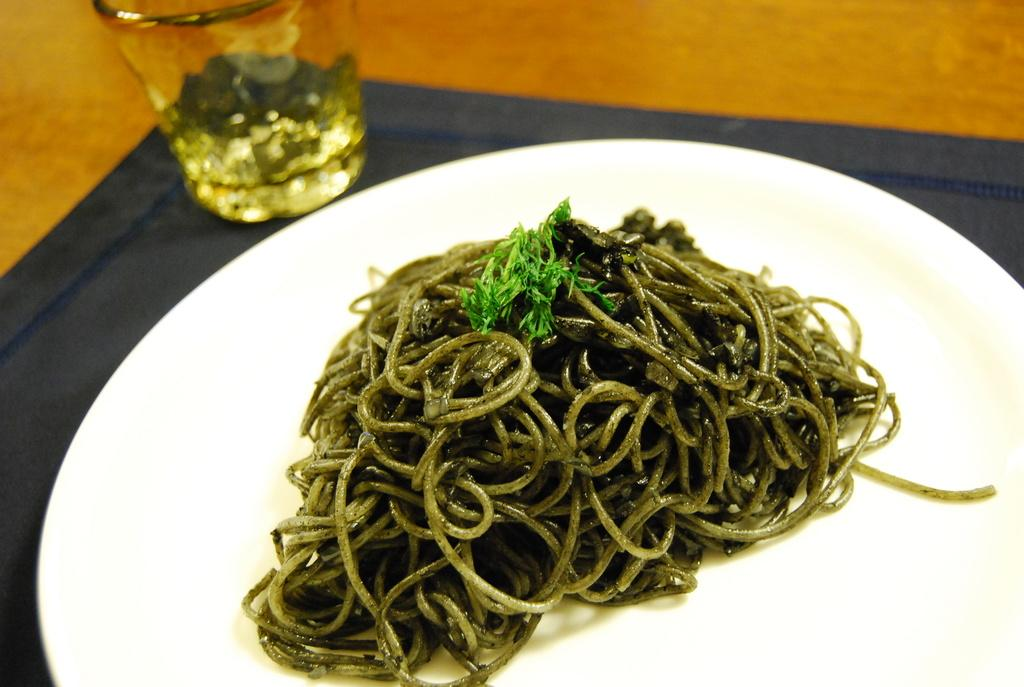What type of food is on the plate in the image? There is a plate containing noodles in the image. What is the other visible item in the image? There is a glass in the top left of the image. What type of oatmeal is being weighed on the scale in the image? There is no oatmeal or scale present in the image. What part of the brain can be seen in the image? There is no brain present in the image. 